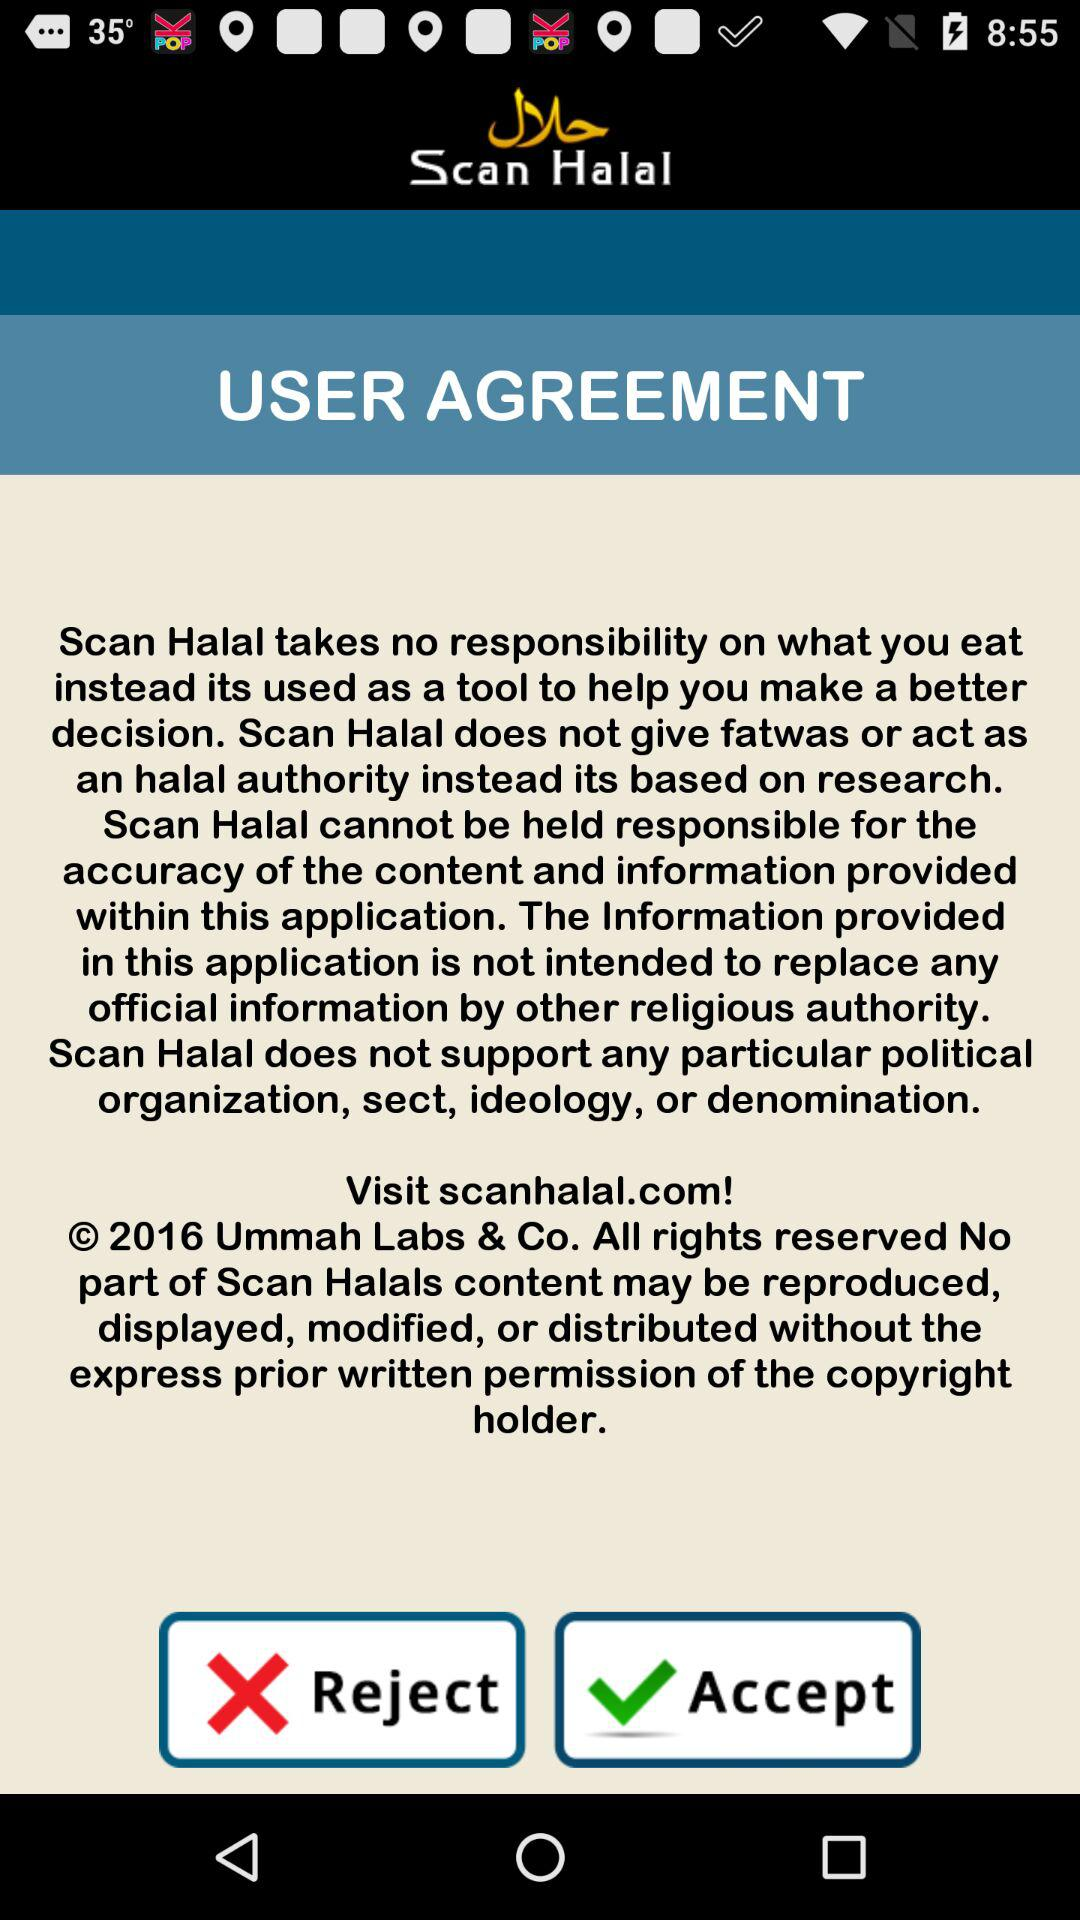What is the year of copyright of the application? The year of copyright is 2016. 